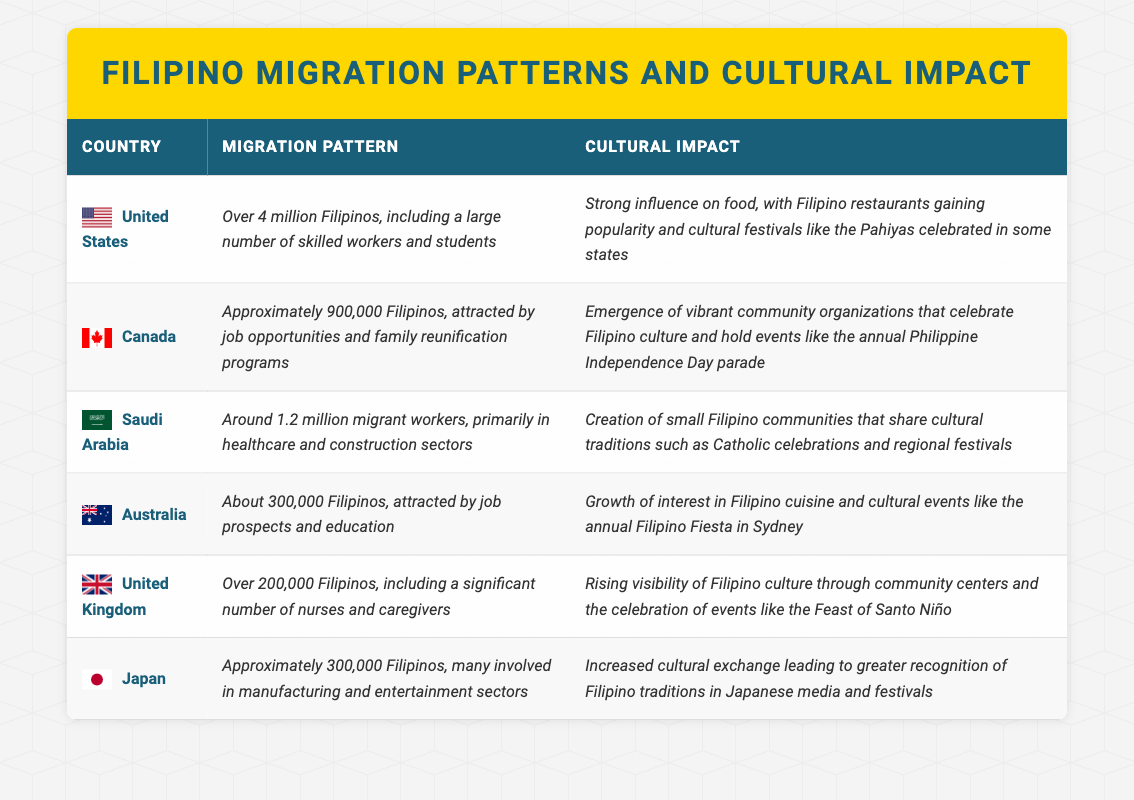What country has the highest number of Filipinos? According to the table, the United States has over 4 million Filipinos, which is the highest figure among all listed countries.
Answer: United States How many Filipinos approximately migrated to Canada? The table states that approximately 900,000 Filipinos have migrated to Canada.
Answer: 900,000 Is the cultural impact of Filipinos in Australia largely related to food? Yes, the table indicates a growth of interest in Filipino cuisine and events, suggesting that food is a significant aspect of cultural impact in Australia.
Answer: Yes Which countries have a noted presence of Filipino nurses and caregivers? Based on the table, the United Kingdom is mentioned for having a significant number of nurses and caregivers among Filipinos, while Saudi Arabia also has a notable number of healthcare workers.
Answer: United Kingdom and Saudi Arabia What is the total number of Filipinos migrating to Japan and Australia combined? By adding the approximately 300,000 Filipinos in Japan and 300,000 in Australia, the total is 600,000.
Answer: 600,000 Do cultural events like the Philippine Independence Day parade occur in Canada? Yes, the table specifically mentions the annual Philippine Independence Day parade as a cultural event in Canada, indicating its occurrence.
Answer: Yes What sector do most Filipinos in Saudi Arabia work in? The table specifies that the majority of Filipinos in Saudi Arabia work in the healthcare and construction sectors.
Answer: Healthcare and construction Which country has the smallest recorded Filipino population in this table? The table shows that Australia has about 300,000 Filipinos, which is the smallest population listed compared to the other countries.
Answer: Australia What impact do Filipinos in the United States have on food culture? The cultural impact in the United States includes a strong influence on food, particularly with the popularity of Filipino restaurants and cultural festivals like Pahiyas.
Answer: Strong influence on food culture How do the cultural impacts of Filipinos in the UK and Japan differ? The UK has a rising visibility of Filipino culture through community centers and specific celebrations, while Japan experiences increased cultural exchange through media and festivals, highlighting a more integrated cultural recognition.
Answer: They differ in community visibility versus media recognition 